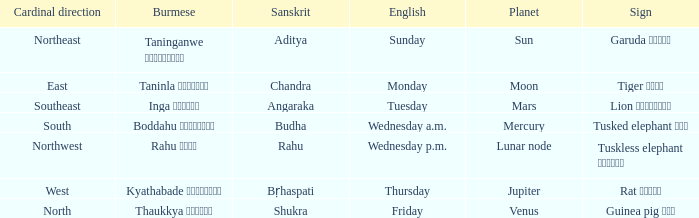What is the planet associated with the direction of south? Mercury. Would you be able to parse every entry in this table? {'header': ['Cardinal direction', 'Burmese', 'Sanskrit', 'English', 'Planet', 'Sign'], 'rows': [['Northeast', 'Taninganwe တနင်္ဂနွေ', 'Aditya', 'Sunday', 'Sun', 'Garuda ဂဠုန်'], ['East', 'Taninla တနင်္လာ', 'Chandra', 'Monday', 'Moon', 'Tiger ကျား'], ['Southeast', 'Inga အင်္ဂါ', 'Angaraka', 'Tuesday', 'Mars', 'Lion ခြင်္သေ့'], ['South', 'Boddahu ဗုဒ္ဓဟူး', 'Budha', 'Wednesday a.m.', 'Mercury', 'Tusked elephant ဆင်'], ['Northwest', 'Rahu ရာဟု', 'Rahu', 'Wednesday p.m.', 'Lunar node', 'Tuskless elephant ဟိုင်း'], ['West', 'Kyathabade ကြာသပတေး', 'Bṛhaspati', 'Thursday', 'Jupiter', 'Rat ကြွက်'], ['North', 'Thaukkya သောကြာ', 'Shukra', 'Friday', 'Venus', 'Guinea pig ပူး']]} 